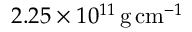Convert formula to latex. <formula><loc_0><loc_0><loc_500><loc_500>2 . 2 5 \times 1 0 ^ { 1 1 } { \, g } { \, c m } ^ { - 1 }</formula> 